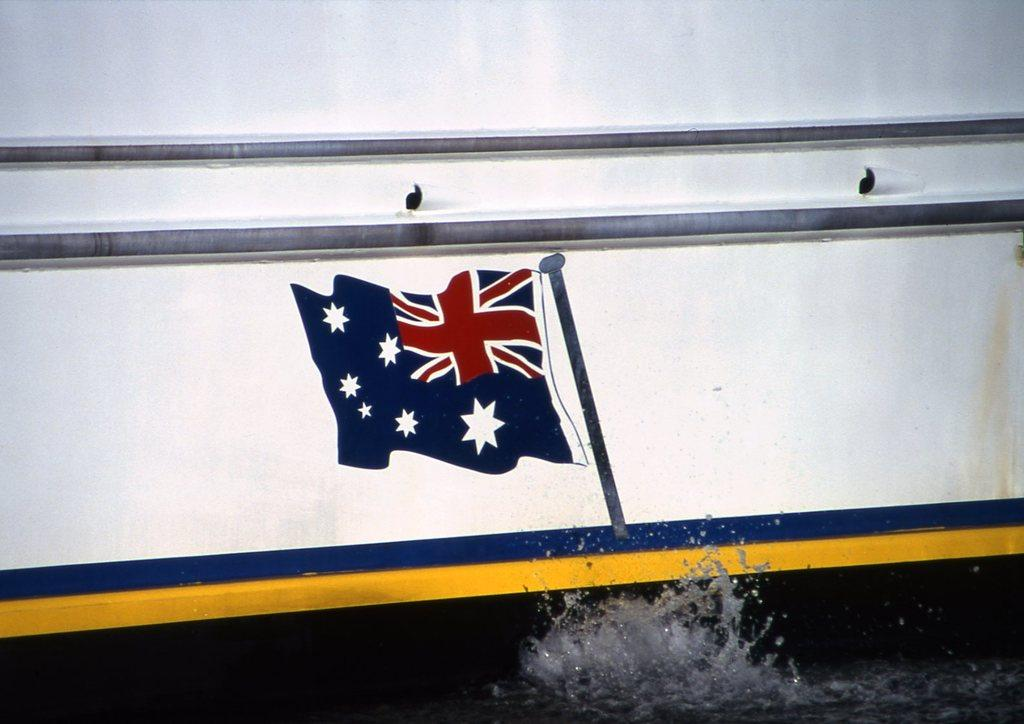What is the main subject of the image? The main subject of the image is a boat. What features can be seen on the boat? Flag poles, a flag, and metal rods are visible on the boat. What is the setting of the image? Water is visible at the bottom of the image. Can you see any jellyfish in the water near the boat? There is no mention of jellyfish in the image, so we cannot determine if any are present. Is there a mountain visible in the background of the image? The image does not show a mountain in the background; it only features a boat and water. 